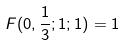Convert formula to latex. <formula><loc_0><loc_0><loc_500><loc_500>F ( 0 , \frac { 1 } { 3 } ; 1 ; 1 ) = 1</formula> 